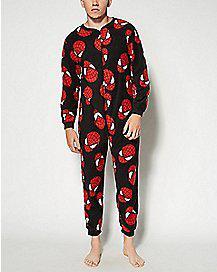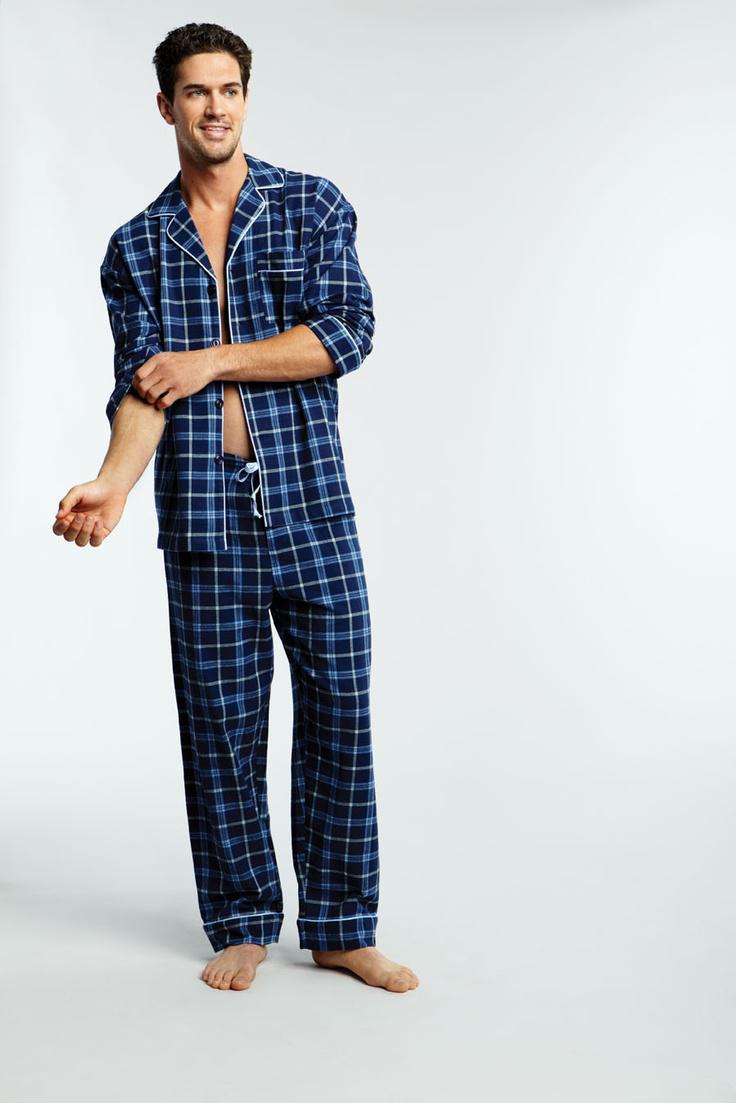The first image is the image on the left, the second image is the image on the right. Evaluate the accuracy of this statement regarding the images: "A model is wearing a one-piece pajama with an all-over print.". Is it true? Answer yes or no. Yes. 